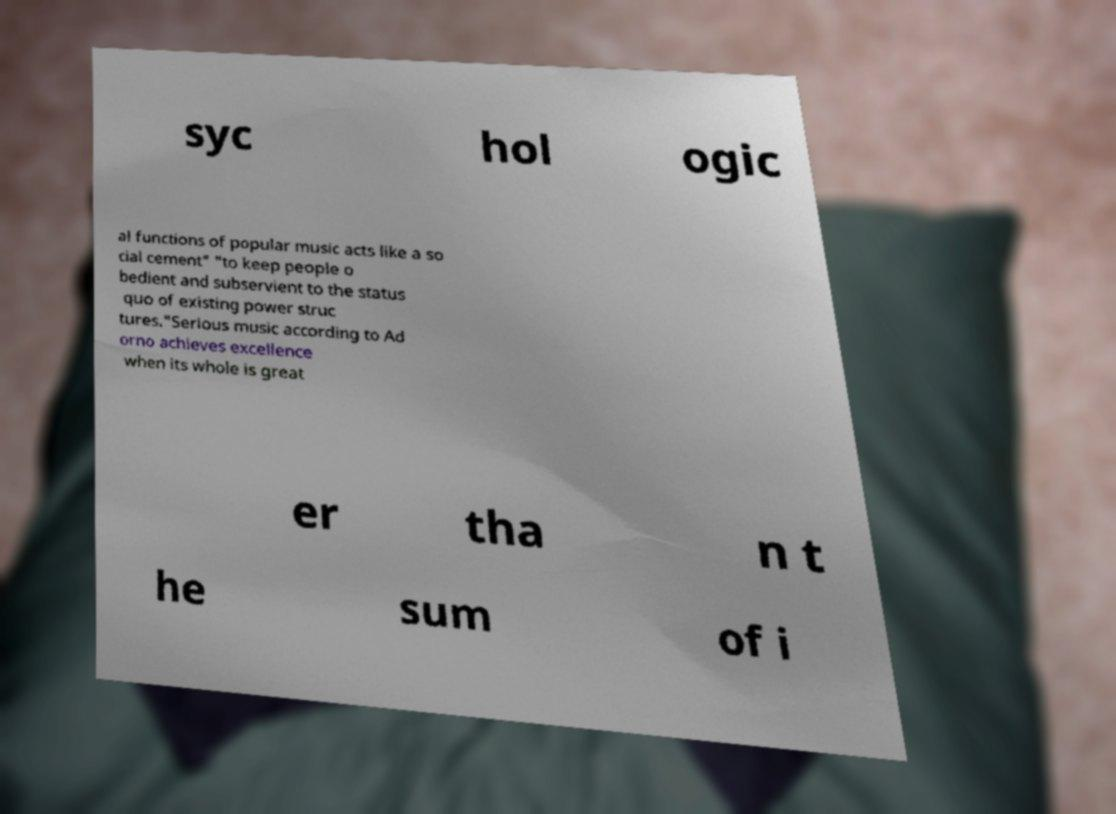There's text embedded in this image that I need extracted. Can you transcribe it verbatim? syc hol ogic al functions of popular music acts like a so cial cement" "to keep people o bedient and subservient to the status quo of existing power struc tures."Serious music according to Ad orno achieves excellence when its whole is great er tha n t he sum of i 